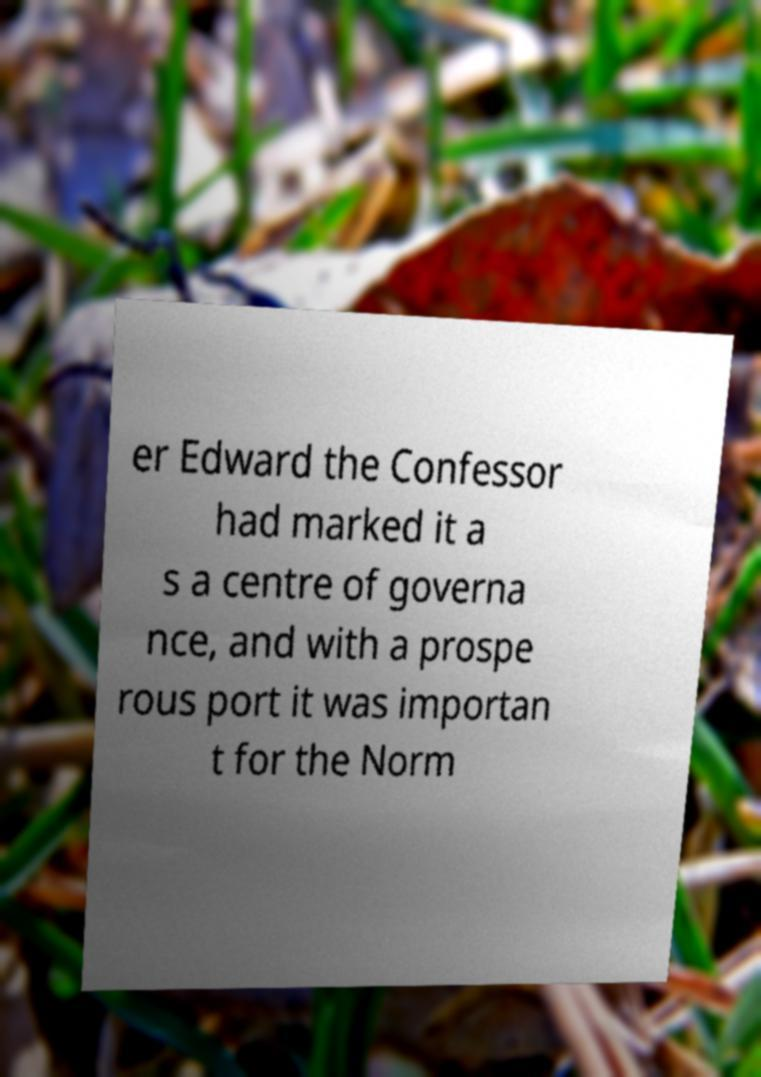Could you extract and type out the text from this image? er Edward the Confessor had marked it a s a centre of governa nce, and with a prospe rous port it was importan t for the Norm 